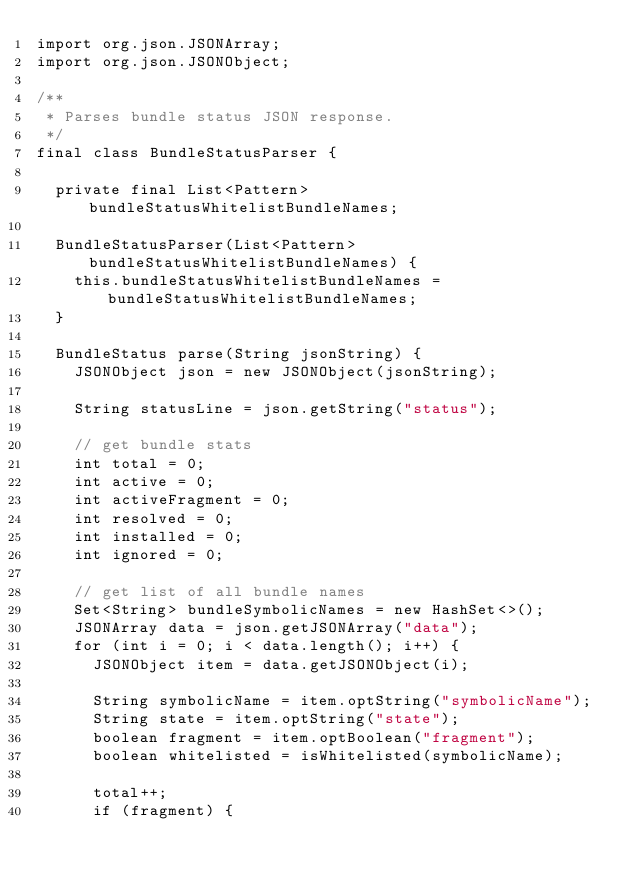<code> <loc_0><loc_0><loc_500><loc_500><_Java_>import org.json.JSONArray;
import org.json.JSONObject;

/**
 * Parses bundle status JSON response.
 */
final class BundleStatusParser {

  private final List<Pattern> bundleStatusWhitelistBundleNames;

  BundleStatusParser(List<Pattern> bundleStatusWhitelistBundleNames) {
    this.bundleStatusWhitelistBundleNames = bundleStatusWhitelistBundleNames;
  }

  BundleStatus parse(String jsonString) {
    JSONObject json = new JSONObject(jsonString);

    String statusLine = json.getString("status");

    // get bundle stats
    int total = 0;
    int active = 0;
    int activeFragment = 0;
    int resolved = 0;
    int installed = 0;
    int ignored = 0;

    // get list of all bundle names
    Set<String> bundleSymbolicNames = new HashSet<>();
    JSONArray data = json.getJSONArray("data");
    for (int i = 0; i < data.length(); i++) {
      JSONObject item = data.getJSONObject(i);

      String symbolicName = item.optString("symbolicName");
      String state = item.optString("state");
      boolean fragment = item.optBoolean("fragment");
      boolean whitelisted = isWhitelisted(symbolicName);

      total++;
      if (fragment) {</code> 